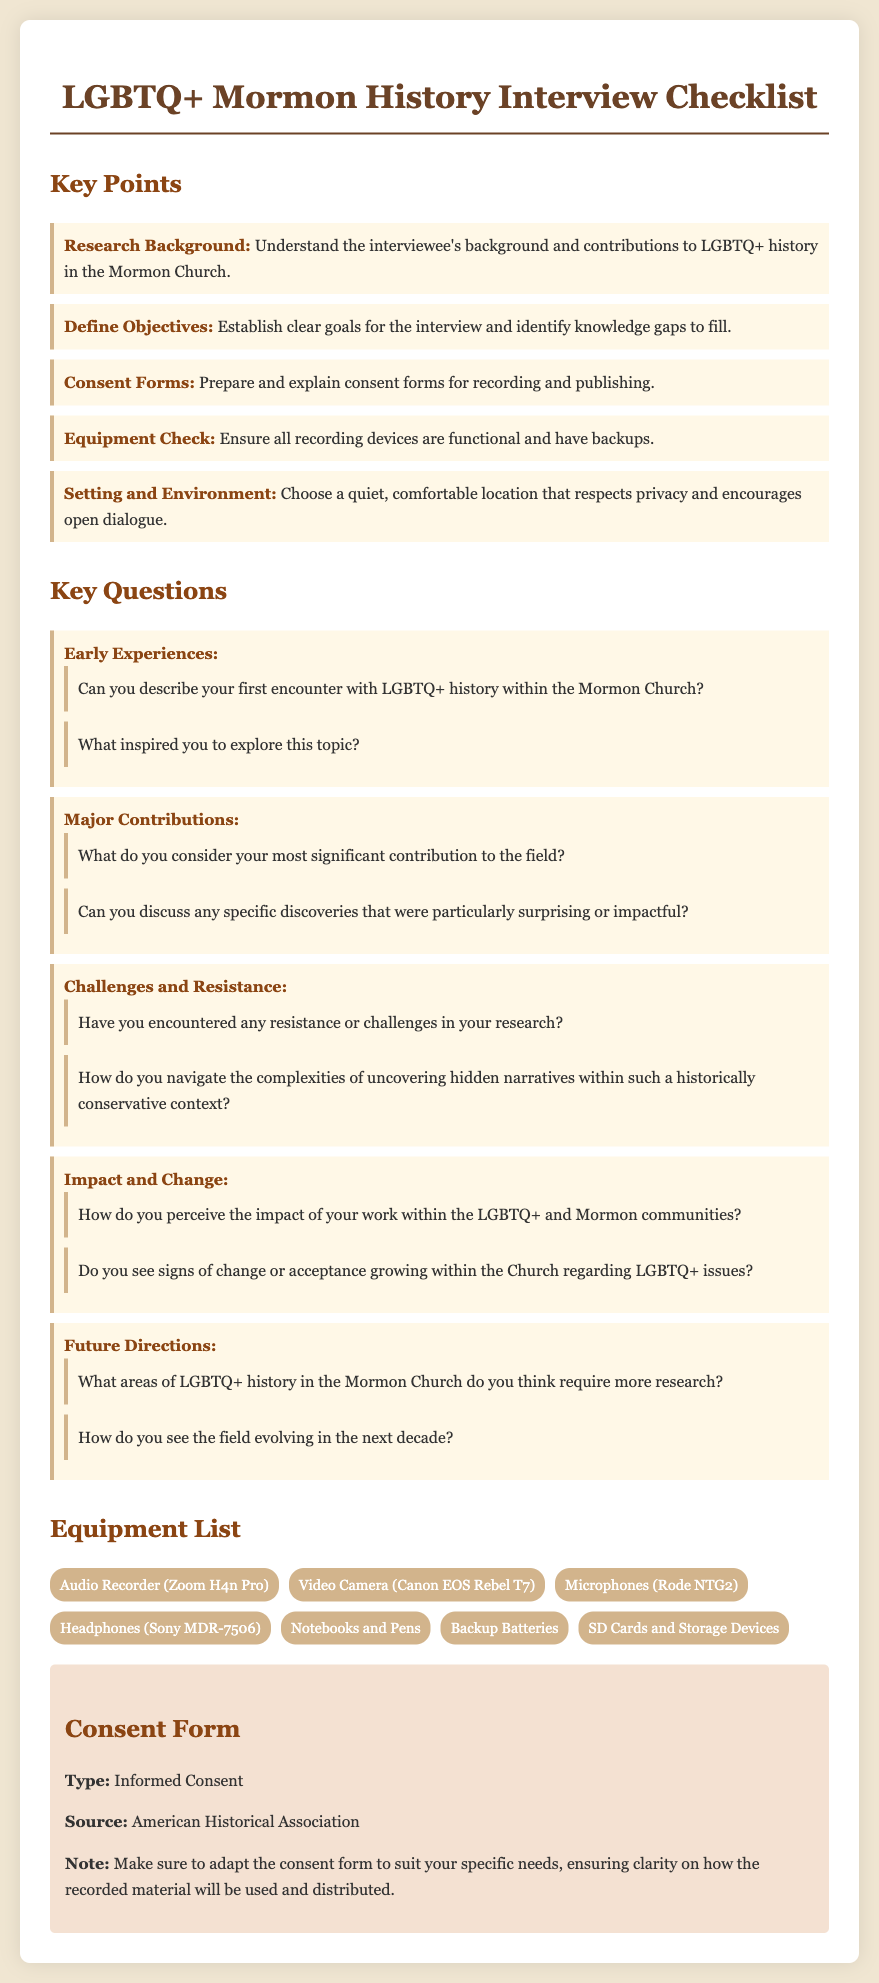What is the title of the checklist? The title of the checklist is stated at the top of the document.
Answer: LGBTQ+ Mormon History Interview Checklist How many key points are listed in the document? The document lists several areas under key points.
Answer: Five Which audio recording device is mentioned in the equipment list? The equipment list specifies various recording devices, including one audio recorder.
Answer: Zoom H4n Pro What type of consent form is included in the document? The document indicates the type of consent form that should be prepared for interviews.
Answer: Informed Consent Who provides the source for the consent form? The source for the consent form is credited in the last section of the document.
Answer: American Historical Association What is the color scheme used in the background of the document? The background color of the document is specified in the CSS styles.
Answer: #f0e6d2 What is one of the major contributions mentioned in the key questions section? The document asks for significant contributions to LGBTQ+ history within the context specified.
Answer: Significant contribution What is one of the challenges mentioned regarding research in the document? The key questions include inquiries about difficulties faced in the research process.
Answer: Resistance What is stated as a future direction in the key questions? Future directions are discussed with regard to areas requiring more research.
Answer: Require more research 